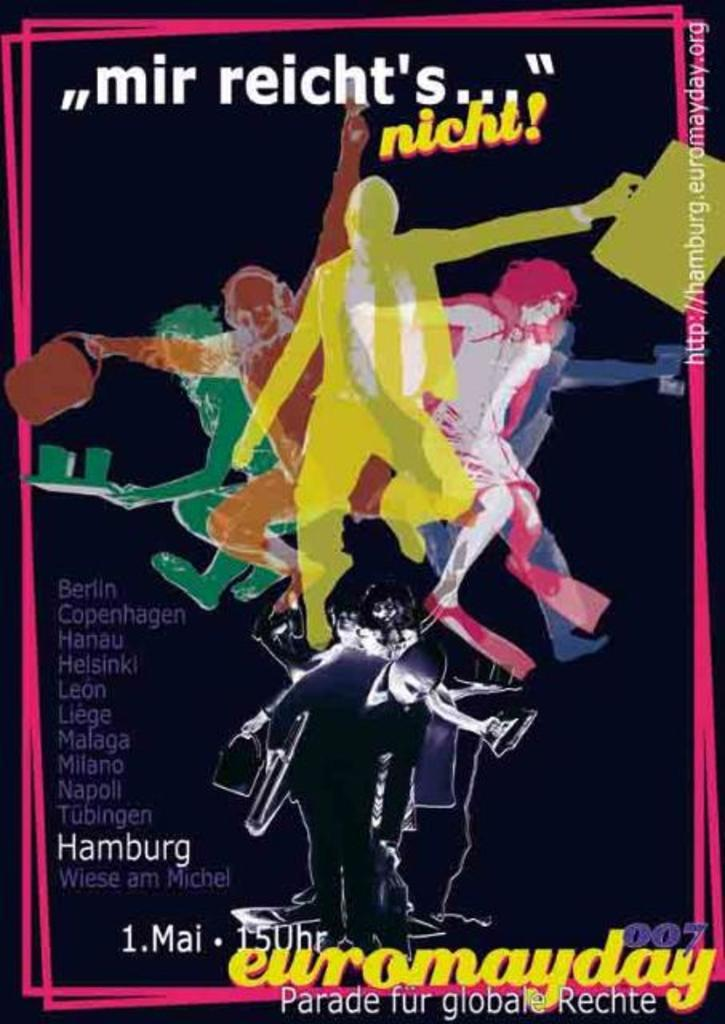Provide a one-sentence caption for the provided image. An event takes place in locations such as Berlin, Copenhagen, Hanau, and Helsinki, among others. 